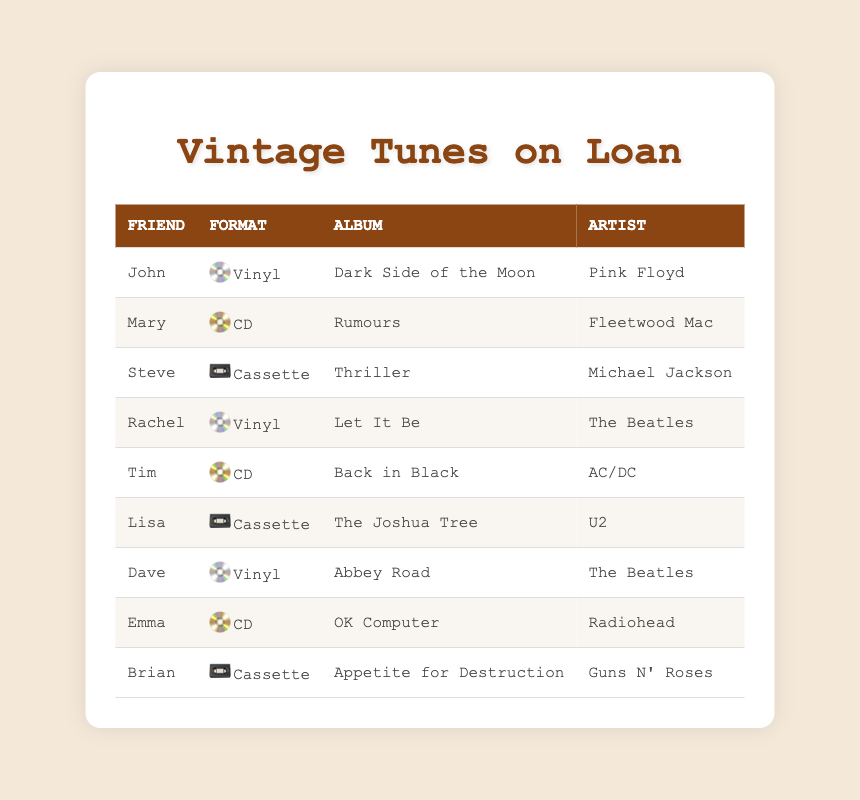What formats of music records have been loaned to friends? The formats of music records mentioned in the table are Vinyl, CD, and Cassette. Each record loaned to a friend corresponds to one of these formats.
Answer: Vinyl, CD, Cassette How many friends borrowed a Vinyl record? There are three entries in the table where the format is Vinyl: John, Rachel, and Dave. Counting these friends gives us a total of three.
Answer: 3 Did any of the friends loan a Cassette record? Yes, there are two instances in the table where the format is Cassette, which correspond to friends Steve and Lisa.
Answer: Yes Who loaned the album "OK Computer"? The table shows that the album "OK Computer" was loaned to Emma, as indicated in the relevant row.
Answer: Emma How many different friends loaned out CD records? The table lists three friends who loaned CD records: Mary, Tim, and Emma. By counting these names, we find there are three distinct friends.
Answer: 3 Which artist has the most albums loaned? The Beatles are represented with two albums loaned out (Let It Be and Abbey Road). No other artist has more than one album loaned. Thus, The Beatles has the most albums loaned.
Answer: The Beatles Is there any friend who has loaned both Vinyl and Cassette records? None of the friends mentioned in the table have loaned both formats; John, Rachel, and Dave loaned Vinyl, while Steve, Lisa, and Brian loaned Cassette, with no overlaps.
Answer: No If I combine the numbers of Vinyl and Cassette formats, how many records are that in total? Counting the records, we have three Vinyl records (John, Rachel, Dave) and three Cassette records (Steve, Lisa, Brian). Adding these gives us 3 + 3 = 6 records in total.
Answer: 6 Who loaned a record by Fleetwood Mac? The table indicates that Mary loaned the album "Rumours" by Fleetwood Mac, as seen in her row.
Answer: Mary 